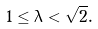Convert formula to latex. <formula><loc_0><loc_0><loc_500><loc_500>1 \leq \lambda < \sqrt { 2 } .</formula> 